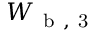Convert formula to latex. <formula><loc_0><loc_0><loc_500><loc_500>W _ { b , 3 }</formula> 